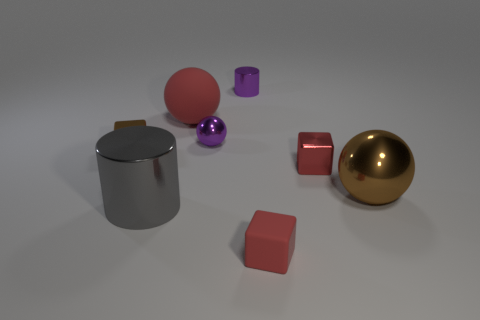Are there more blue balls than purple metallic balls?
Keep it short and to the point. No. There is a small metallic block that is in front of the tiny metallic cube left of the large sphere that is left of the large brown metal ball; what color is it?
Your answer should be very brief. Red. There is a tiny object that is in front of the large brown object; does it have the same color as the small metal block on the right side of the large red sphere?
Your answer should be compact. Yes. What number of purple shiny balls are to the left of the metallic cylinder that is in front of the brown ball?
Provide a short and direct response. 0. Are there any red rubber cubes?
Make the answer very short. Yes. How many other things are the same color as the small matte object?
Ensure brevity in your answer.  2. Are there fewer rubber cubes than small red things?
Give a very brief answer. Yes. There is a big metallic thing left of the large sphere left of the tiny cylinder; what shape is it?
Provide a short and direct response. Cylinder. Are there any large cylinders to the right of the big brown metal sphere?
Provide a short and direct response. No. What color is the shiny ball that is the same size as the gray shiny cylinder?
Offer a terse response. Brown. 